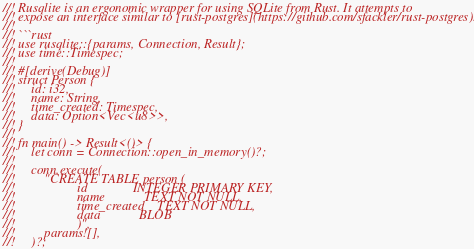<code> <loc_0><loc_0><loc_500><loc_500><_Rust_>//! Rusqlite is an ergonomic wrapper for using SQLite from Rust. It attempts to
//! expose an interface similar to [rust-postgres](https://github.com/sfackler/rust-postgres).
//!
//! ```rust
//! use rusqlite::{params, Connection, Result};
//! use time::Timespec;
//!
//! #[derive(Debug)]
//! struct Person {
//!     id: i32,
//!     name: String,
//!     time_created: Timespec,
//!     data: Option<Vec<u8>>,
//! }
//!
//! fn main() -> Result<()> {
//!     let conn = Connection::open_in_memory()?;
//!
//!     conn.execute(
//!         "CREATE TABLE person (
//!                   id              INTEGER PRIMARY KEY,
//!                   name            TEXT NOT NULL,
//!                   time_created    TEXT NOT NULL,
//!                   data            BLOB
//!                   )",
//!         params![],
//!     )?;</code> 